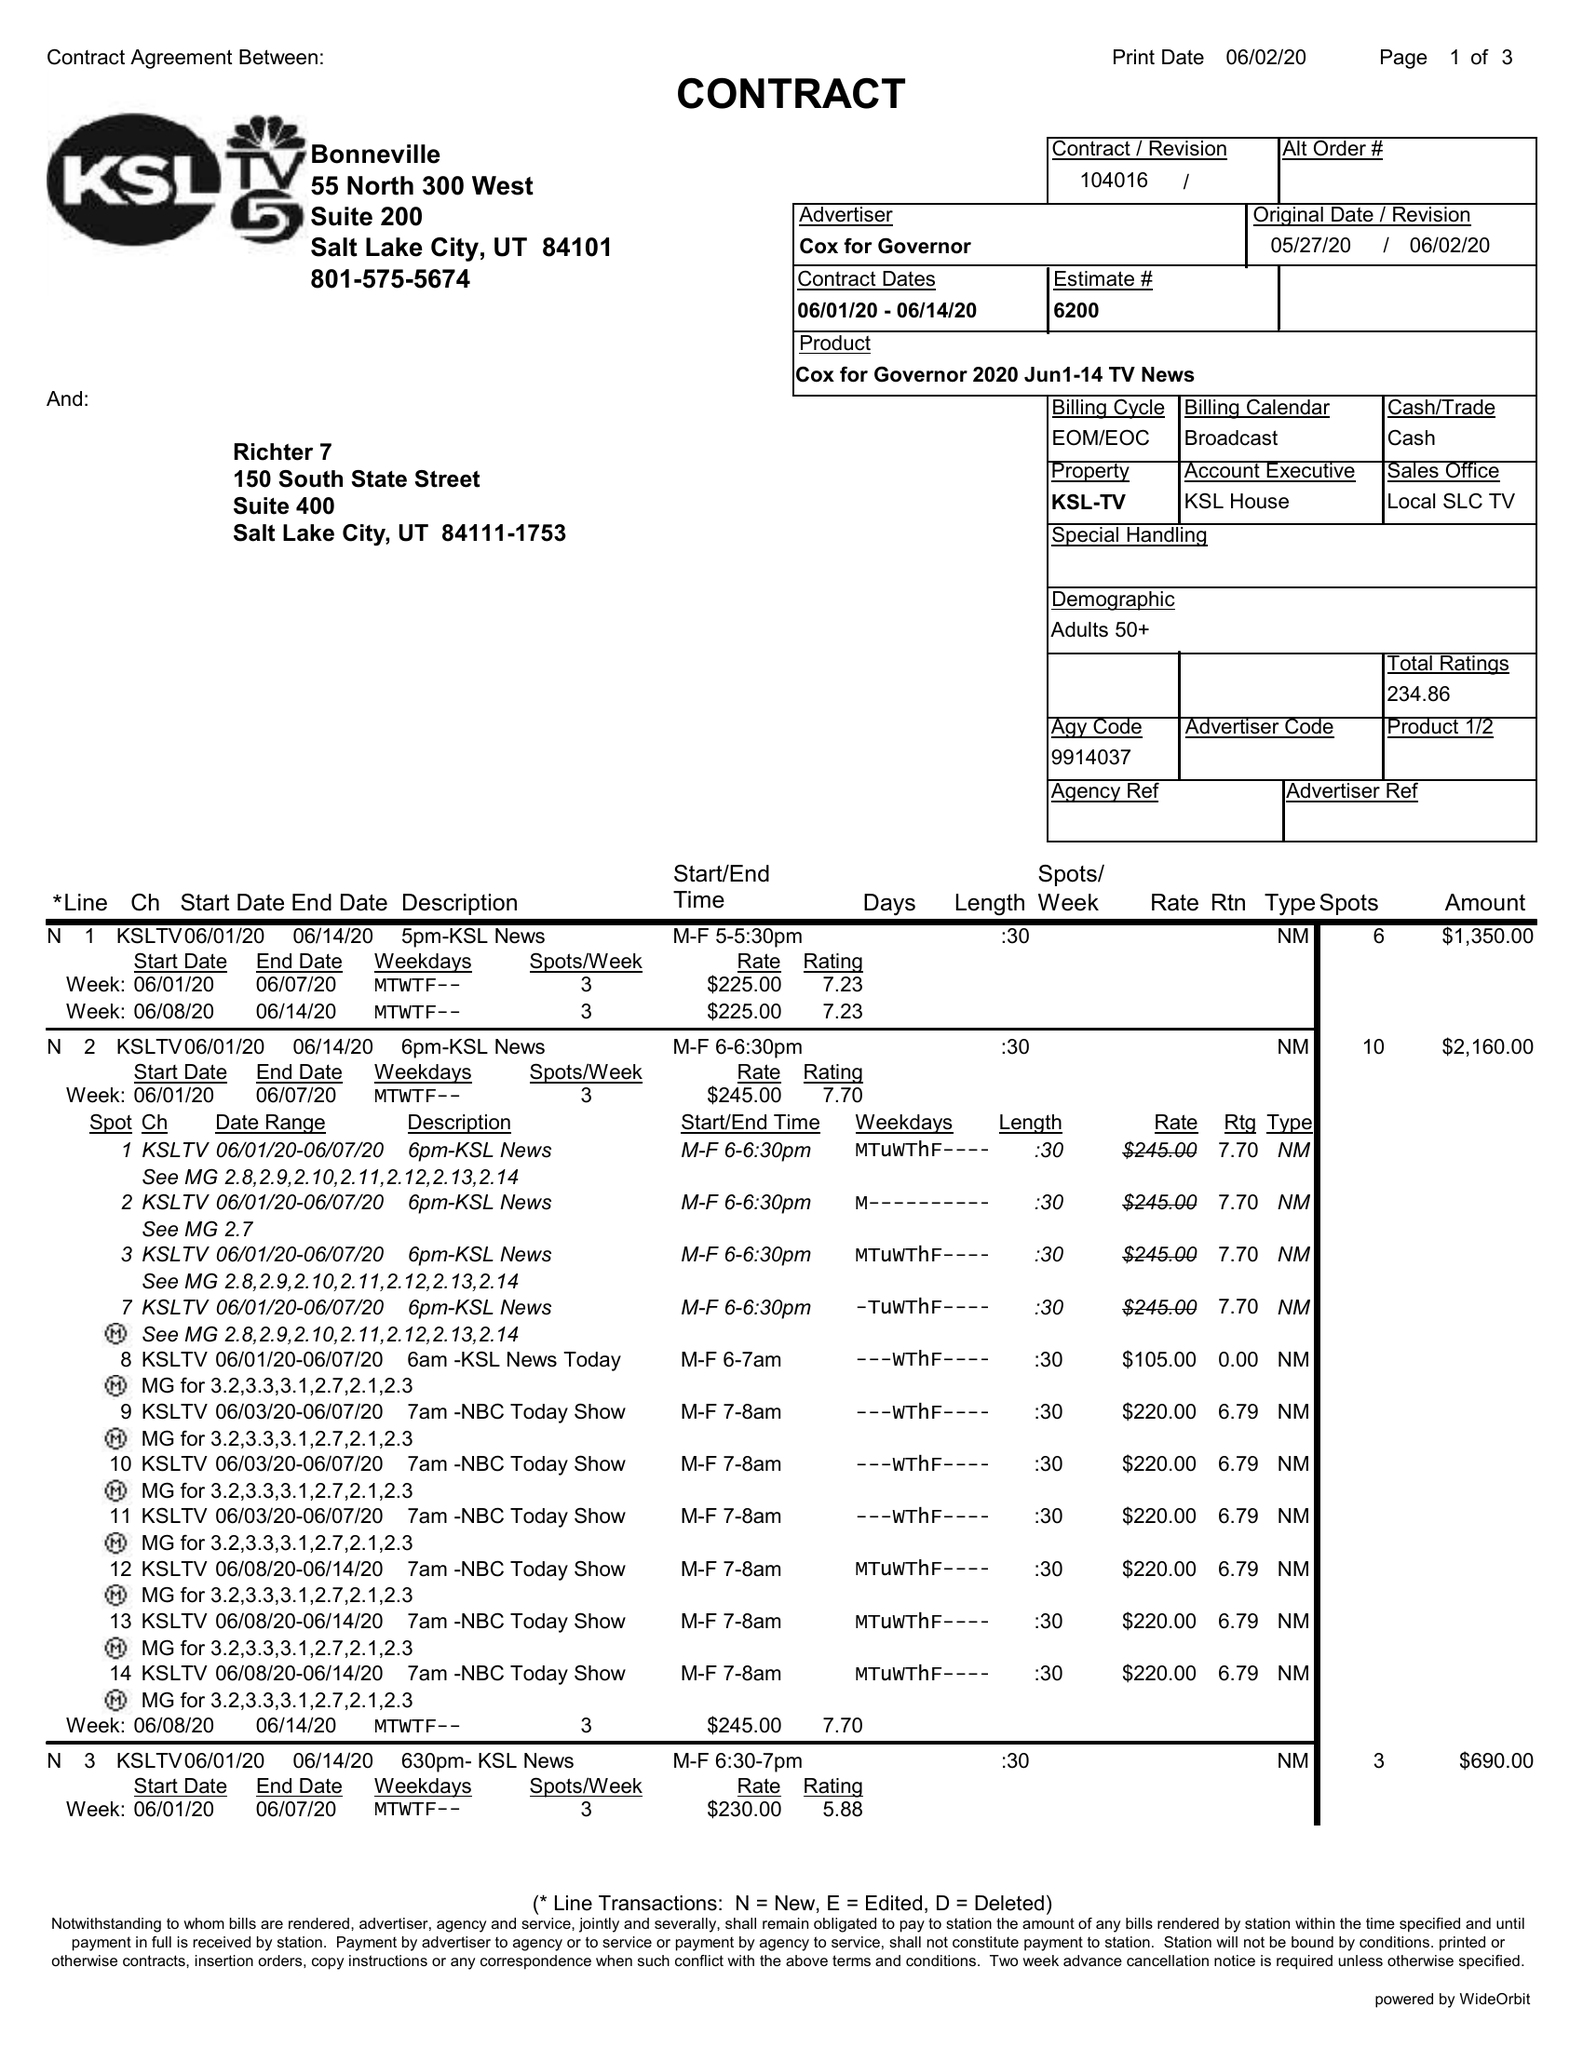What is the value for the gross_amount?
Answer the question using a single word or phrase. 12830.00 